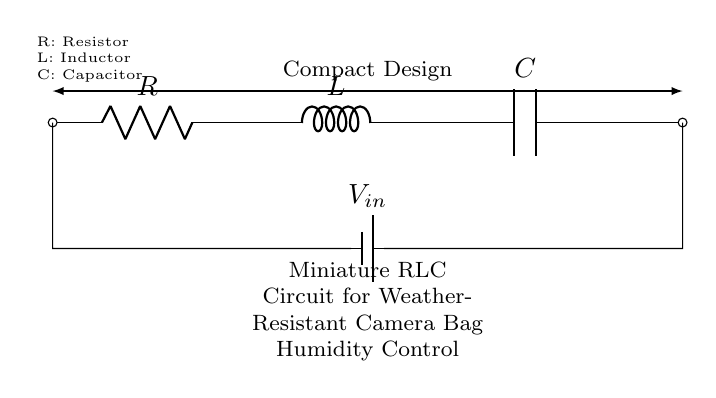What does R represent in the circuit? R stands for Resistor, which limits the flow of current within the circuit. It is one of the basic components of an RLC circuit.
Answer: Resistor What is the purpose of the inductor in this circuit? The inductor stores energy in the form of a magnetic field when current flows through it, which can affect the circuit's response to changes in current and support the control of humidity.
Answer: Energy storage How many components are there in this RLC circuit? The circuit contains three main components: a resistor, an inductor, and a capacitor.
Answer: Three What is the role of C in this circuit? C represents the Capacitor, which stores electrical energy in an electric field and helps smoothen the voltage fluctuations in the circuit, contributing to humidity control.
Answer: Capacitor How does the RLC circuit behave under humidity control conditions? The RLC circuit can create oscillations or damped responses to regulate humidity levels in the camera bag, balancing the effects of resistance, inductance, and capacitance to maintain stable conditions.
Answer: Oscillations What is the relationship between R, L, and C in determining the circuit's response? The relationship is governed by the values of the resistor, inductor, and capacitor and affects the circuit's resonance frequency, which determines how the circuit responds to humidity changes.
Answer: Resonance frequency 